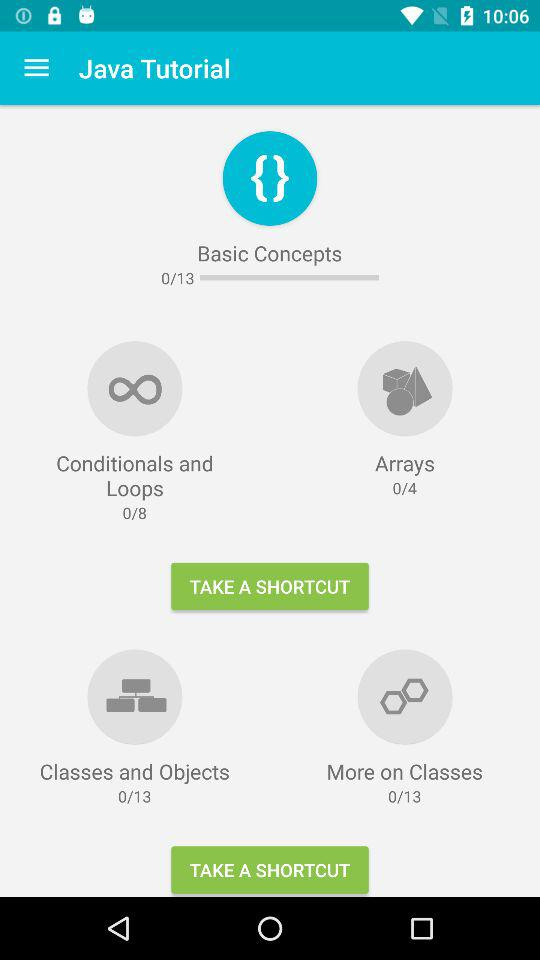What is the total number of arrays in the Java tutorial? The total number of arrays is 0. 